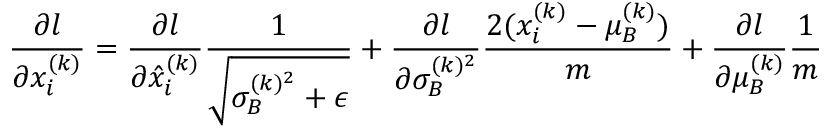Convert formula to latex. <formula><loc_0><loc_0><loc_500><loc_500>{ \frac { \partial l } { \partial x _ { i } ^ { ( k ) } } } = { \frac { \partial l } { \partial { \hat { x } } _ { i } ^ { ( k ) } } } { \frac { 1 } { \sqrt { \sigma _ { B } ^ { ( k ) ^ { 2 } } + \epsilon } } } + { \frac { \partial l } { \partial \sigma _ { B } ^ { ( k ) ^ { 2 } } } } { \frac { 2 ( x _ { i } ^ { ( k ) } - \mu _ { B } ^ { ( k ) } ) } { m } } + { \frac { \partial l } { \partial \mu _ { B } ^ { ( k ) } } } { \frac { 1 } { m } }</formula> 